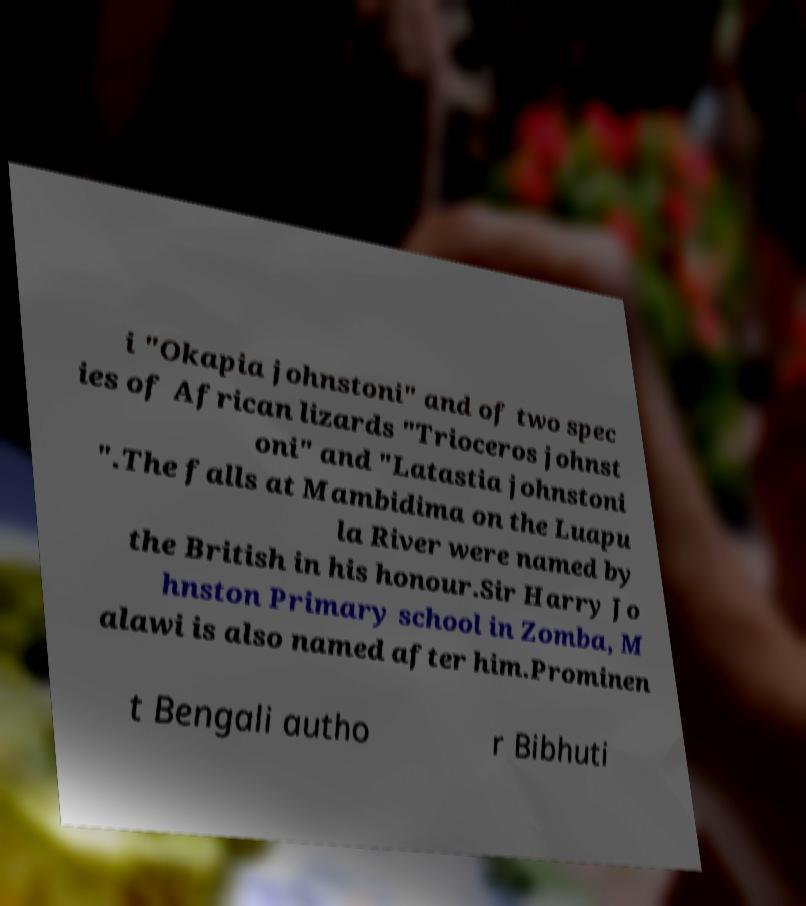I need the written content from this picture converted into text. Can you do that? i "Okapia johnstoni" and of two spec ies of African lizards "Trioceros johnst oni" and "Latastia johnstoni ".The falls at Mambidima on the Luapu la River were named by the British in his honour.Sir Harry Jo hnston Primary school in Zomba, M alawi is also named after him.Prominen t Bengali autho r Bibhuti 